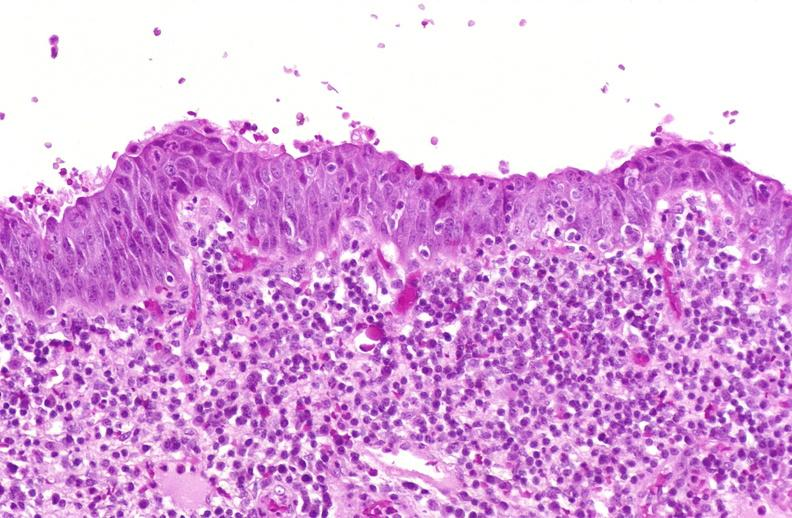does this image show squamous metaplasia, renal pelvis due to nephrolithiasis?
Answer the question using a single word or phrase. Yes 